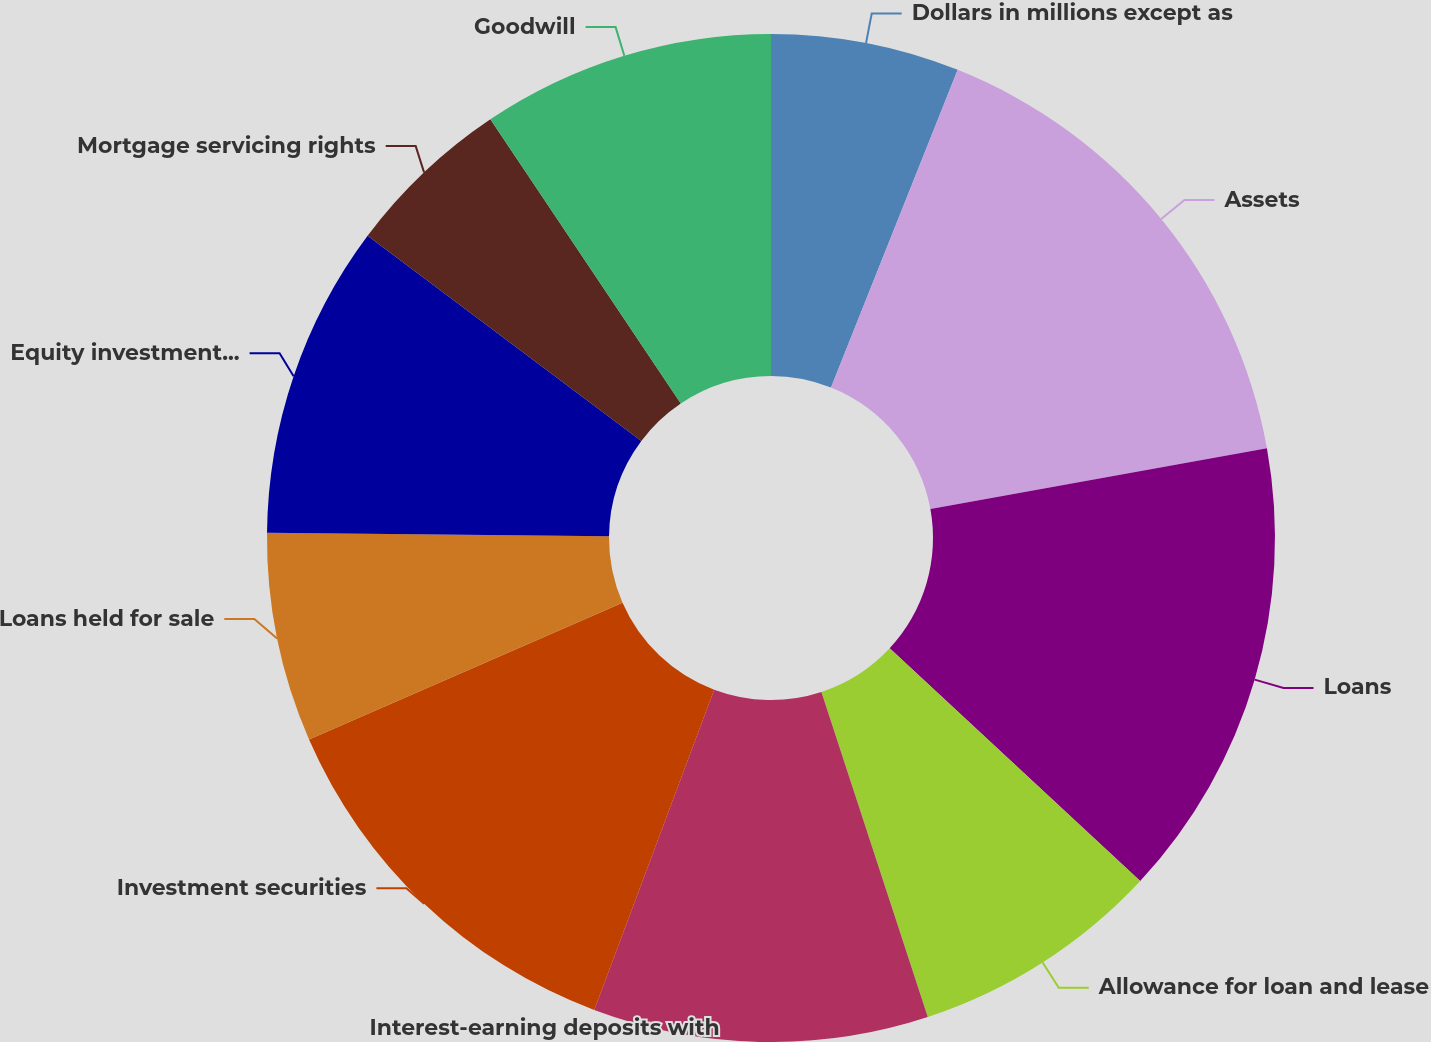Convert chart to OTSL. <chart><loc_0><loc_0><loc_500><loc_500><pie_chart><fcel>Dollars in millions except as<fcel>Assets<fcel>Loans<fcel>Allowance for loan and lease<fcel>Interest-earning deposits with<fcel>Investment securities<fcel>Loans held for sale<fcel>Equity investments (b)<fcel>Mortgage servicing rights<fcel>Goodwill<nl><fcel>6.04%<fcel>16.11%<fcel>14.77%<fcel>8.05%<fcel>10.74%<fcel>12.75%<fcel>6.71%<fcel>10.07%<fcel>5.37%<fcel>9.4%<nl></chart> 